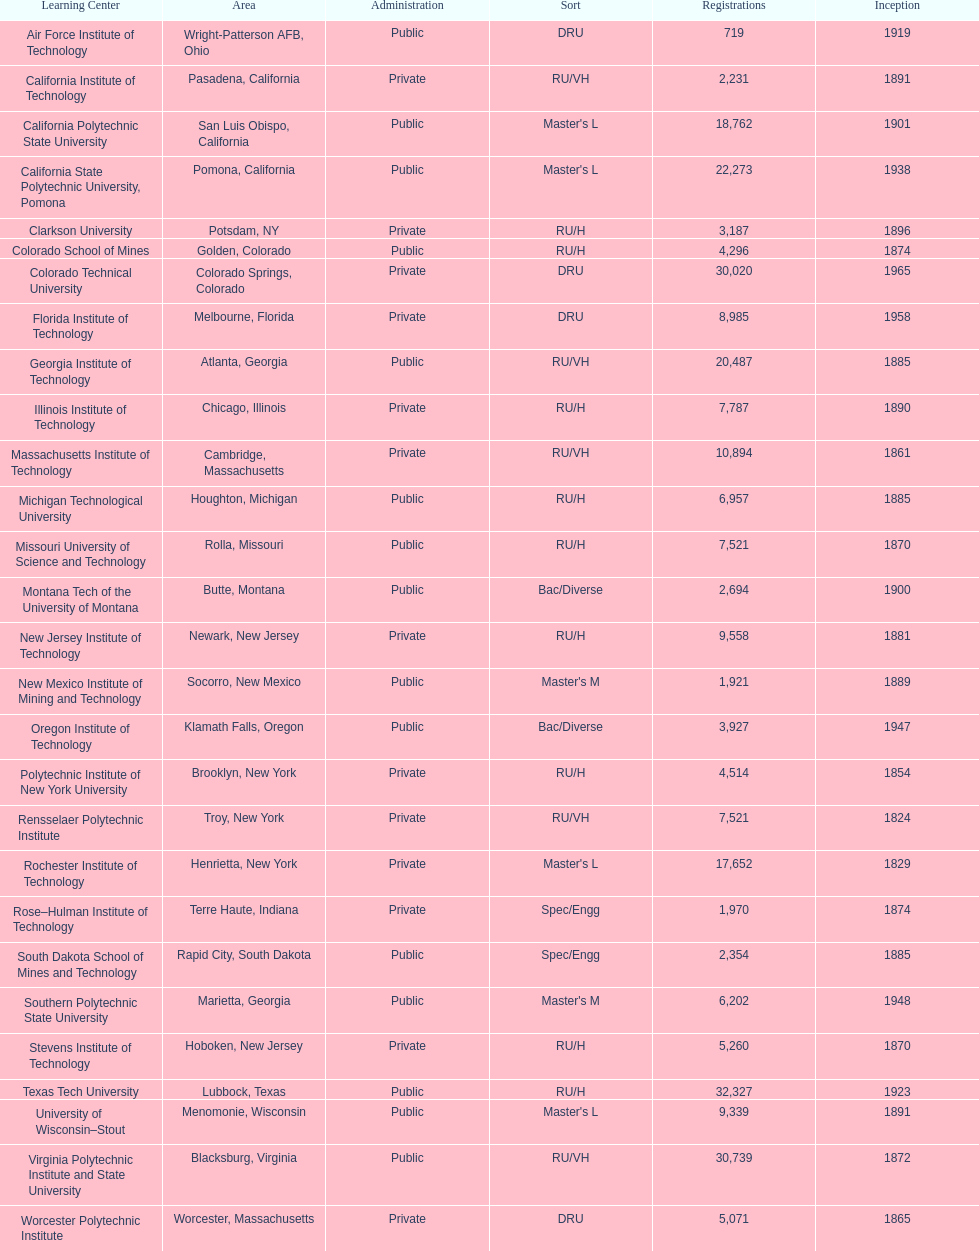How many of the universities were located in california? 3. 